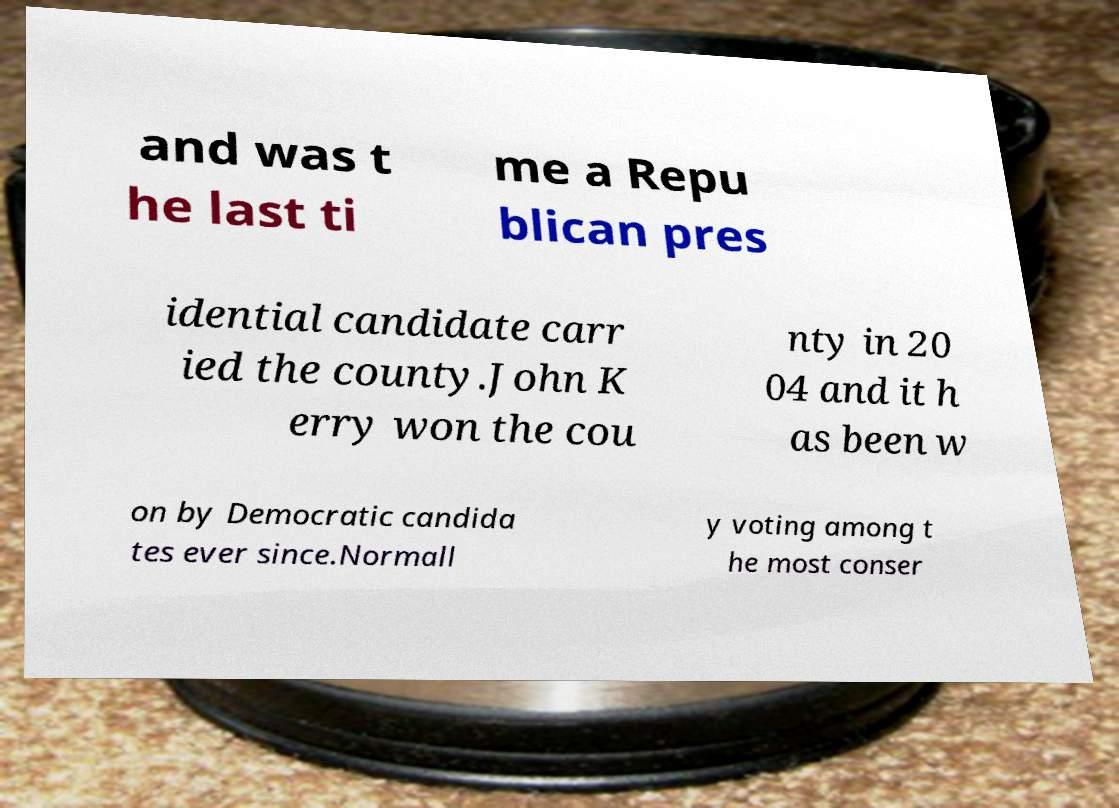Could you assist in decoding the text presented in this image and type it out clearly? and was t he last ti me a Repu blican pres idential candidate carr ied the county.John K erry won the cou nty in 20 04 and it h as been w on by Democratic candida tes ever since.Normall y voting among t he most conser 